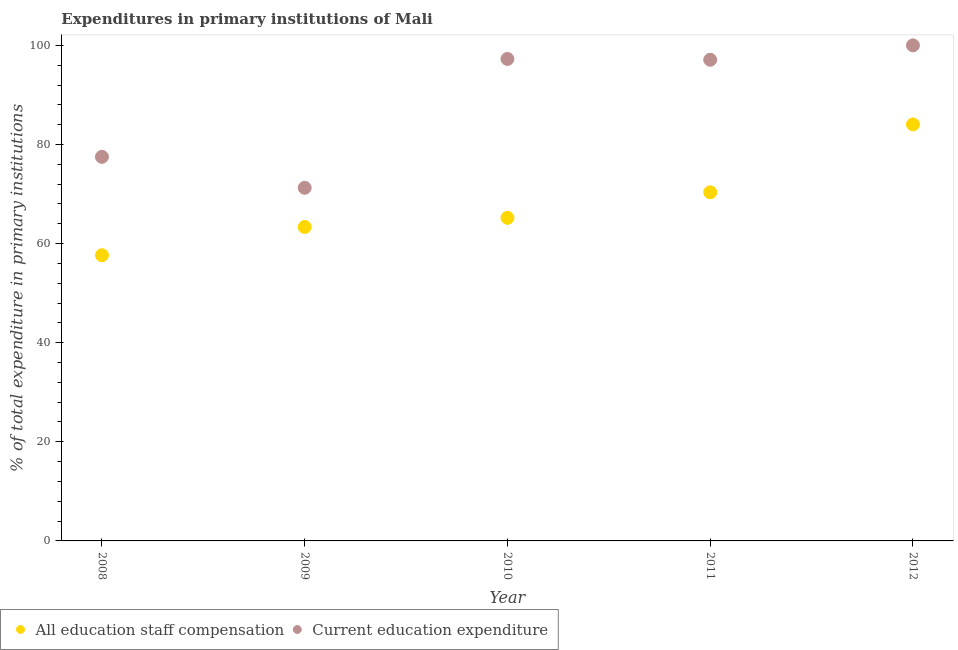How many different coloured dotlines are there?
Your response must be concise. 2. Is the number of dotlines equal to the number of legend labels?
Keep it short and to the point. Yes. What is the expenditure in staff compensation in 2011?
Your response must be concise. 70.35. Across all years, what is the maximum expenditure in education?
Your answer should be very brief. 100. Across all years, what is the minimum expenditure in education?
Give a very brief answer. 71.26. In which year was the expenditure in staff compensation maximum?
Make the answer very short. 2012. What is the total expenditure in staff compensation in the graph?
Ensure brevity in your answer.  340.58. What is the difference between the expenditure in staff compensation in 2008 and that in 2009?
Offer a very short reply. -5.7. What is the difference between the expenditure in staff compensation in 2008 and the expenditure in education in 2009?
Keep it short and to the point. -13.61. What is the average expenditure in education per year?
Keep it short and to the point. 88.62. In the year 2008, what is the difference between the expenditure in education and expenditure in staff compensation?
Offer a very short reply. 19.86. What is the ratio of the expenditure in staff compensation in 2009 to that in 2012?
Offer a very short reply. 0.75. What is the difference between the highest and the second highest expenditure in education?
Provide a short and direct response. 2.74. What is the difference between the highest and the lowest expenditure in education?
Your response must be concise. 28.74. Is the sum of the expenditure in education in 2008 and 2010 greater than the maximum expenditure in staff compensation across all years?
Give a very brief answer. Yes. Is the expenditure in education strictly greater than the expenditure in staff compensation over the years?
Offer a terse response. Yes. What is the difference between two consecutive major ticks on the Y-axis?
Offer a terse response. 20. Are the values on the major ticks of Y-axis written in scientific E-notation?
Keep it short and to the point. No. What is the title of the graph?
Your answer should be compact. Expenditures in primary institutions of Mali. Does "Long-term debt" appear as one of the legend labels in the graph?
Make the answer very short. No. What is the label or title of the X-axis?
Offer a terse response. Year. What is the label or title of the Y-axis?
Your answer should be compact. % of total expenditure in primary institutions. What is the % of total expenditure in primary institutions of All education staff compensation in 2008?
Keep it short and to the point. 57.65. What is the % of total expenditure in primary institutions of Current education expenditure in 2008?
Ensure brevity in your answer.  77.51. What is the % of total expenditure in primary institutions of All education staff compensation in 2009?
Offer a terse response. 63.35. What is the % of total expenditure in primary institutions in Current education expenditure in 2009?
Ensure brevity in your answer.  71.26. What is the % of total expenditure in primary institutions of All education staff compensation in 2010?
Offer a very short reply. 65.2. What is the % of total expenditure in primary institutions of Current education expenditure in 2010?
Your answer should be very brief. 97.26. What is the % of total expenditure in primary institutions of All education staff compensation in 2011?
Make the answer very short. 70.35. What is the % of total expenditure in primary institutions in Current education expenditure in 2011?
Your answer should be compact. 97.09. What is the % of total expenditure in primary institutions of All education staff compensation in 2012?
Give a very brief answer. 84.04. Across all years, what is the maximum % of total expenditure in primary institutions in All education staff compensation?
Your answer should be very brief. 84.04. Across all years, what is the maximum % of total expenditure in primary institutions of Current education expenditure?
Offer a very short reply. 100. Across all years, what is the minimum % of total expenditure in primary institutions of All education staff compensation?
Your response must be concise. 57.65. Across all years, what is the minimum % of total expenditure in primary institutions of Current education expenditure?
Your answer should be very brief. 71.26. What is the total % of total expenditure in primary institutions in All education staff compensation in the graph?
Make the answer very short. 340.58. What is the total % of total expenditure in primary institutions of Current education expenditure in the graph?
Keep it short and to the point. 443.12. What is the difference between the % of total expenditure in primary institutions of All education staff compensation in 2008 and that in 2009?
Provide a succinct answer. -5.7. What is the difference between the % of total expenditure in primary institutions in Current education expenditure in 2008 and that in 2009?
Provide a short and direct response. 6.25. What is the difference between the % of total expenditure in primary institutions of All education staff compensation in 2008 and that in 2010?
Your response must be concise. -7.55. What is the difference between the % of total expenditure in primary institutions in Current education expenditure in 2008 and that in 2010?
Offer a very short reply. -19.76. What is the difference between the % of total expenditure in primary institutions in All education staff compensation in 2008 and that in 2011?
Ensure brevity in your answer.  -12.7. What is the difference between the % of total expenditure in primary institutions in Current education expenditure in 2008 and that in 2011?
Provide a short and direct response. -19.59. What is the difference between the % of total expenditure in primary institutions in All education staff compensation in 2008 and that in 2012?
Give a very brief answer. -26.39. What is the difference between the % of total expenditure in primary institutions in Current education expenditure in 2008 and that in 2012?
Your answer should be very brief. -22.49. What is the difference between the % of total expenditure in primary institutions in All education staff compensation in 2009 and that in 2010?
Your answer should be very brief. -1.85. What is the difference between the % of total expenditure in primary institutions in Current education expenditure in 2009 and that in 2010?
Make the answer very short. -26. What is the difference between the % of total expenditure in primary institutions of All education staff compensation in 2009 and that in 2011?
Your answer should be very brief. -7. What is the difference between the % of total expenditure in primary institutions in Current education expenditure in 2009 and that in 2011?
Your answer should be very brief. -25.83. What is the difference between the % of total expenditure in primary institutions of All education staff compensation in 2009 and that in 2012?
Your answer should be very brief. -20.69. What is the difference between the % of total expenditure in primary institutions of Current education expenditure in 2009 and that in 2012?
Give a very brief answer. -28.74. What is the difference between the % of total expenditure in primary institutions of All education staff compensation in 2010 and that in 2011?
Your answer should be compact. -5.15. What is the difference between the % of total expenditure in primary institutions of Current education expenditure in 2010 and that in 2011?
Provide a succinct answer. 0.17. What is the difference between the % of total expenditure in primary institutions in All education staff compensation in 2010 and that in 2012?
Provide a succinct answer. -18.84. What is the difference between the % of total expenditure in primary institutions of Current education expenditure in 2010 and that in 2012?
Your answer should be compact. -2.74. What is the difference between the % of total expenditure in primary institutions of All education staff compensation in 2011 and that in 2012?
Your answer should be compact. -13.69. What is the difference between the % of total expenditure in primary institutions in Current education expenditure in 2011 and that in 2012?
Provide a short and direct response. -2.91. What is the difference between the % of total expenditure in primary institutions in All education staff compensation in 2008 and the % of total expenditure in primary institutions in Current education expenditure in 2009?
Your response must be concise. -13.61. What is the difference between the % of total expenditure in primary institutions of All education staff compensation in 2008 and the % of total expenditure in primary institutions of Current education expenditure in 2010?
Offer a very short reply. -39.61. What is the difference between the % of total expenditure in primary institutions of All education staff compensation in 2008 and the % of total expenditure in primary institutions of Current education expenditure in 2011?
Make the answer very short. -39.44. What is the difference between the % of total expenditure in primary institutions in All education staff compensation in 2008 and the % of total expenditure in primary institutions in Current education expenditure in 2012?
Provide a short and direct response. -42.35. What is the difference between the % of total expenditure in primary institutions in All education staff compensation in 2009 and the % of total expenditure in primary institutions in Current education expenditure in 2010?
Keep it short and to the point. -33.92. What is the difference between the % of total expenditure in primary institutions of All education staff compensation in 2009 and the % of total expenditure in primary institutions of Current education expenditure in 2011?
Give a very brief answer. -33.75. What is the difference between the % of total expenditure in primary institutions of All education staff compensation in 2009 and the % of total expenditure in primary institutions of Current education expenditure in 2012?
Your response must be concise. -36.65. What is the difference between the % of total expenditure in primary institutions in All education staff compensation in 2010 and the % of total expenditure in primary institutions in Current education expenditure in 2011?
Make the answer very short. -31.89. What is the difference between the % of total expenditure in primary institutions of All education staff compensation in 2010 and the % of total expenditure in primary institutions of Current education expenditure in 2012?
Provide a short and direct response. -34.8. What is the difference between the % of total expenditure in primary institutions of All education staff compensation in 2011 and the % of total expenditure in primary institutions of Current education expenditure in 2012?
Keep it short and to the point. -29.65. What is the average % of total expenditure in primary institutions of All education staff compensation per year?
Offer a very short reply. 68.12. What is the average % of total expenditure in primary institutions of Current education expenditure per year?
Your answer should be compact. 88.62. In the year 2008, what is the difference between the % of total expenditure in primary institutions of All education staff compensation and % of total expenditure in primary institutions of Current education expenditure?
Your answer should be compact. -19.86. In the year 2009, what is the difference between the % of total expenditure in primary institutions of All education staff compensation and % of total expenditure in primary institutions of Current education expenditure?
Your answer should be compact. -7.91. In the year 2010, what is the difference between the % of total expenditure in primary institutions of All education staff compensation and % of total expenditure in primary institutions of Current education expenditure?
Provide a short and direct response. -32.06. In the year 2011, what is the difference between the % of total expenditure in primary institutions of All education staff compensation and % of total expenditure in primary institutions of Current education expenditure?
Your answer should be very brief. -26.75. In the year 2012, what is the difference between the % of total expenditure in primary institutions in All education staff compensation and % of total expenditure in primary institutions in Current education expenditure?
Offer a terse response. -15.96. What is the ratio of the % of total expenditure in primary institutions in All education staff compensation in 2008 to that in 2009?
Make the answer very short. 0.91. What is the ratio of the % of total expenditure in primary institutions in Current education expenditure in 2008 to that in 2009?
Provide a short and direct response. 1.09. What is the ratio of the % of total expenditure in primary institutions in All education staff compensation in 2008 to that in 2010?
Your answer should be very brief. 0.88. What is the ratio of the % of total expenditure in primary institutions in Current education expenditure in 2008 to that in 2010?
Provide a succinct answer. 0.8. What is the ratio of the % of total expenditure in primary institutions in All education staff compensation in 2008 to that in 2011?
Your answer should be very brief. 0.82. What is the ratio of the % of total expenditure in primary institutions of Current education expenditure in 2008 to that in 2011?
Offer a very short reply. 0.8. What is the ratio of the % of total expenditure in primary institutions in All education staff compensation in 2008 to that in 2012?
Your response must be concise. 0.69. What is the ratio of the % of total expenditure in primary institutions of Current education expenditure in 2008 to that in 2012?
Your answer should be very brief. 0.78. What is the ratio of the % of total expenditure in primary institutions of All education staff compensation in 2009 to that in 2010?
Make the answer very short. 0.97. What is the ratio of the % of total expenditure in primary institutions of Current education expenditure in 2009 to that in 2010?
Your answer should be very brief. 0.73. What is the ratio of the % of total expenditure in primary institutions in All education staff compensation in 2009 to that in 2011?
Keep it short and to the point. 0.9. What is the ratio of the % of total expenditure in primary institutions of Current education expenditure in 2009 to that in 2011?
Make the answer very short. 0.73. What is the ratio of the % of total expenditure in primary institutions of All education staff compensation in 2009 to that in 2012?
Your answer should be very brief. 0.75. What is the ratio of the % of total expenditure in primary institutions in Current education expenditure in 2009 to that in 2012?
Your answer should be compact. 0.71. What is the ratio of the % of total expenditure in primary institutions in All education staff compensation in 2010 to that in 2011?
Offer a very short reply. 0.93. What is the ratio of the % of total expenditure in primary institutions of All education staff compensation in 2010 to that in 2012?
Your answer should be very brief. 0.78. What is the ratio of the % of total expenditure in primary institutions in Current education expenditure in 2010 to that in 2012?
Your answer should be very brief. 0.97. What is the ratio of the % of total expenditure in primary institutions in All education staff compensation in 2011 to that in 2012?
Give a very brief answer. 0.84. What is the ratio of the % of total expenditure in primary institutions in Current education expenditure in 2011 to that in 2012?
Your response must be concise. 0.97. What is the difference between the highest and the second highest % of total expenditure in primary institutions of All education staff compensation?
Make the answer very short. 13.69. What is the difference between the highest and the second highest % of total expenditure in primary institutions of Current education expenditure?
Ensure brevity in your answer.  2.74. What is the difference between the highest and the lowest % of total expenditure in primary institutions in All education staff compensation?
Your response must be concise. 26.39. What is the difference between the highest and the lowest % of total expenditure in primary institutions of Current education expenditure?
Your response must be concise. 28.74. 